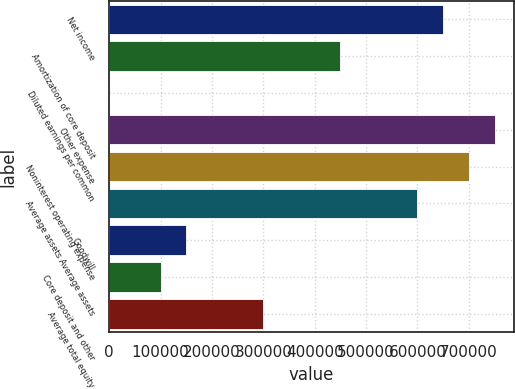Convert chart. <chart><loc_0><loc_0><loc_500><loc_500><bar_chart><fcel>Net income<fcel>Amortization of core deposit<fcel>Diluted earnings per common<fcel>Other expense<fcel>Noninterest operating expense<fcel>Average assets Average assets<fcel>Goodwill<fcel>Core deposit and other<fcel>Average total equity<nl><fcel>650072<fcel>450050<fcel>0.97<fcel>750083<fcel>700078<fcel>600067<fcel>150017<fcel>100012<fcel>300034<nl></chart> 